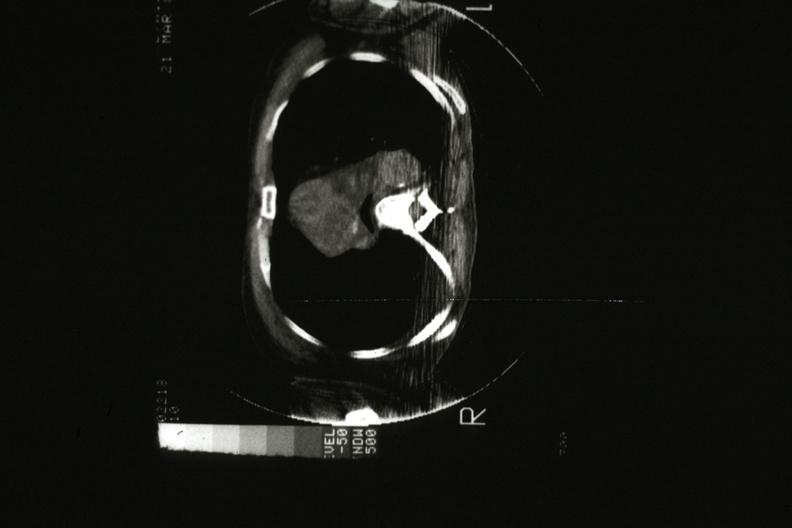what does cat scan?
Answer the question using a single word or phrase. Showing tumor mass invading superior vena ca 